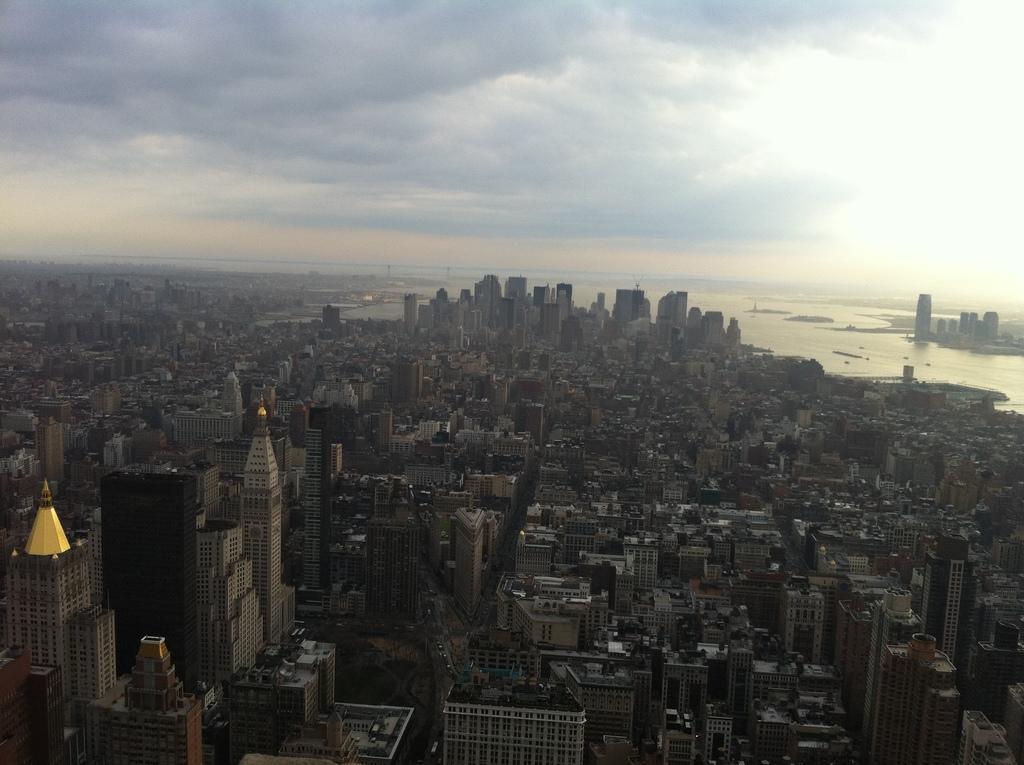Please provide a concise description of this image. This is the top view of the city, in this image there are buildings and a river, at the top of the image there are clouds in the sky. 